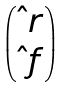Convert formula to latex. <formula><loc_0><loc_0><loc_500><loc_500>\begin{pmatrix} \hat { \ } r \\ \hat { \ } f \end{pmatrix}</formula> 